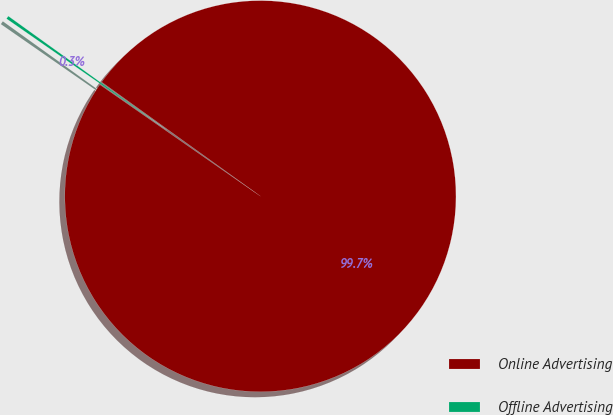<chart> <loc_0><loc_0><loc_500><loc_500><pie_chart><fcel>Online Advertising<fcel>Offline Advertising<nl><fcel>99.74%<fcel>0.26%<nl></chart> 